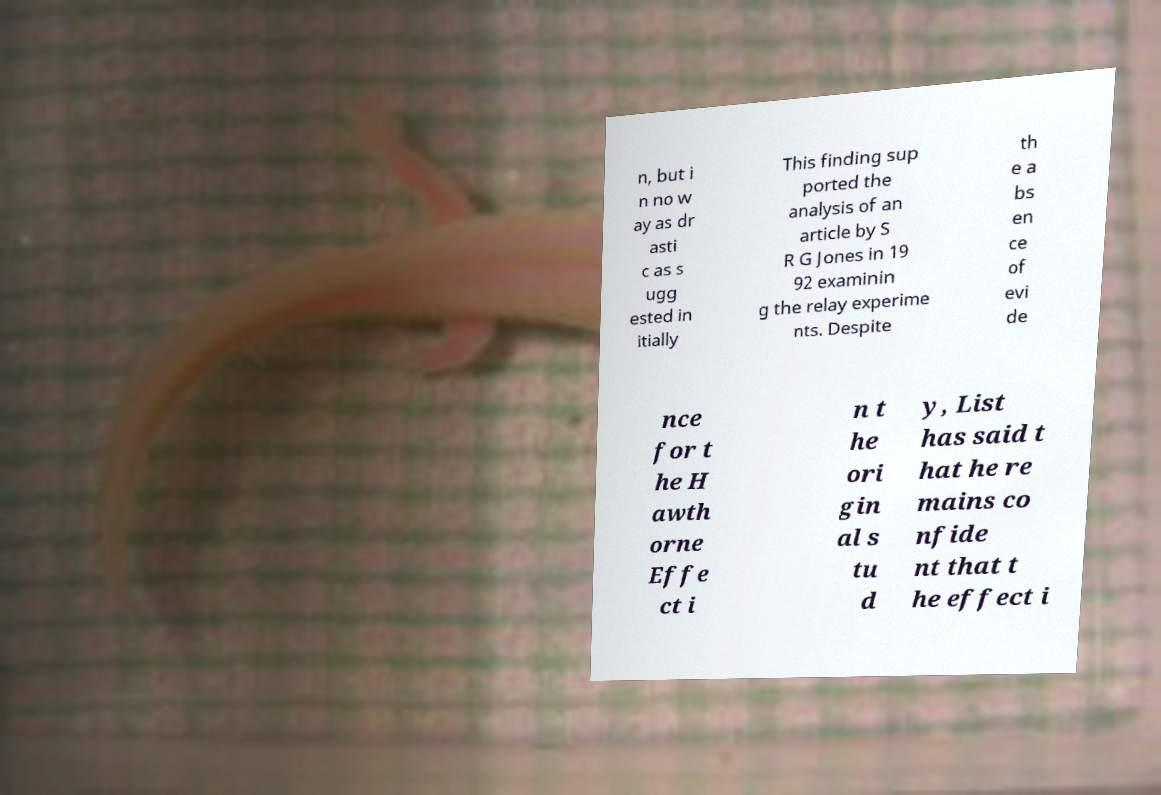What messages or text are displayed in this image? I need them in a readable, typed format. n, but i n no w ay as dr asti c as s ugg ested in itially This finding sup ported the analysis of an article by S R G Jones in 19 92 examinin g the relay experime nts. Despite th e a bs en ce of evi de nce for t he H awth orne Effe ct i n t he ori gin al s tu d y, List has said t hat he re mains co nfide nt that t he effect i 